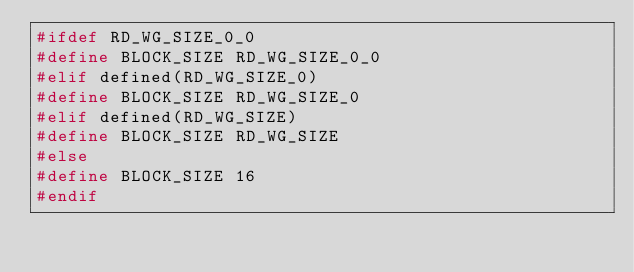<code> <loc_0><loc_0><loc_500><loc_500><_C++_>#ifdef RD_WG_SIZE_0_0
#define BLOCK_SIZE RD_WG_SIZE_0_0
#elif defined(RD_WG_SIZE_0)
#define BLOCK_SIZE RD_WG_SIZE_0
#elif defined(RD_WG_SIZE)
#define BLOCK_SIZE RD_WG_SIZE
#else
#define BLOCK_SIZE 16
#endif
</code> 